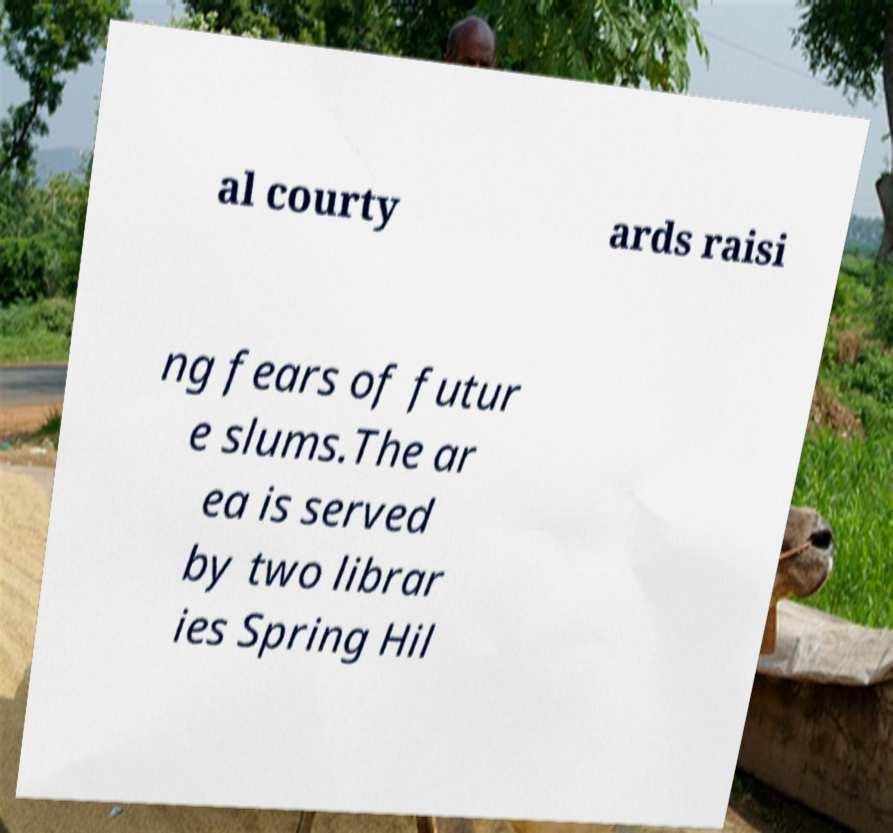Could you assist in decoding the text presented in this image and type it out clearly? al courty ards raisi ng fears of futur e slums.The ar ea is served by two librar ies Spring Hil 